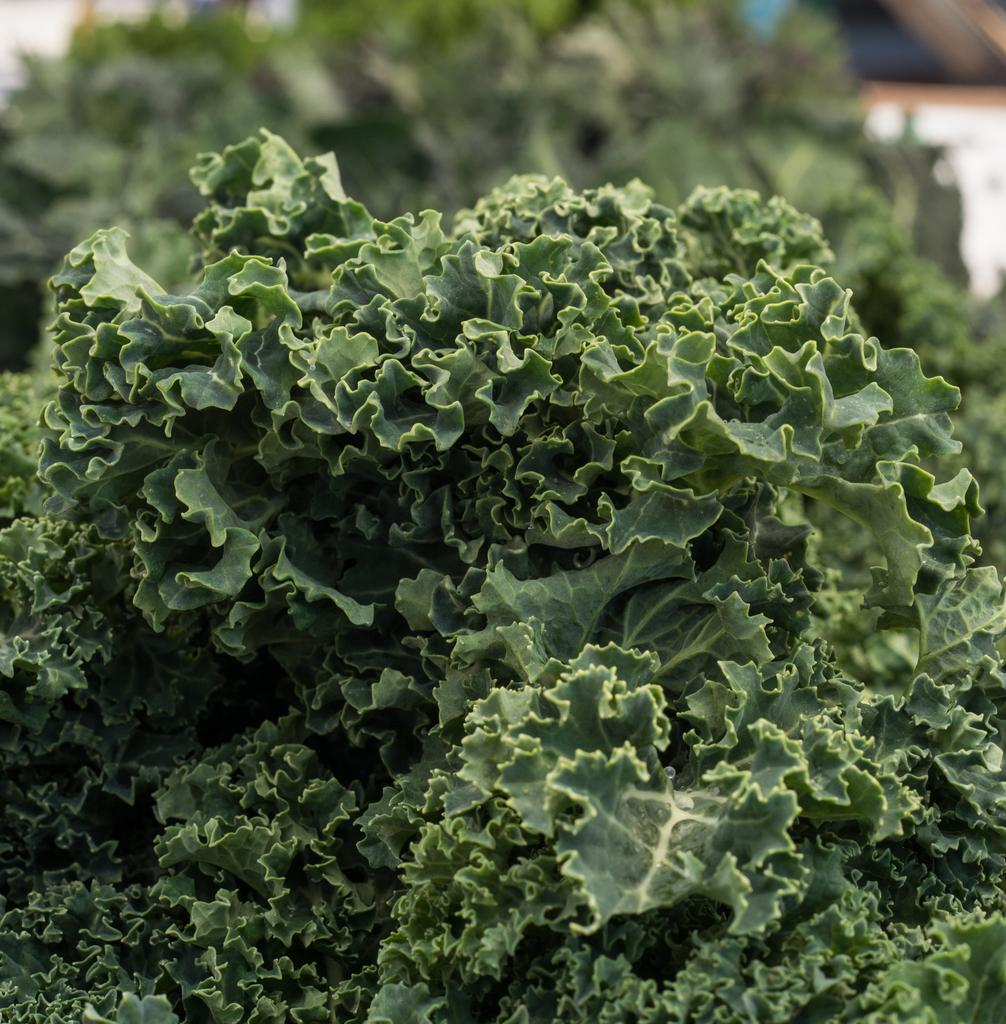What is the main subject of the image? The main subject of the image is a zoom-in picture of leaves. Can you describe the leaves in the image? Unfortunately, the facts provided do not give any details about the leaves, so we cannot describe them. What is the cause of the war depicted in the image? There is no war depicted in the image, as it is a zoom-in picture of leaves. How many spiders can be seen crawling on the leaves in the image? There are no spiders present in the image, as it is a zoom-in picture of leaves. 